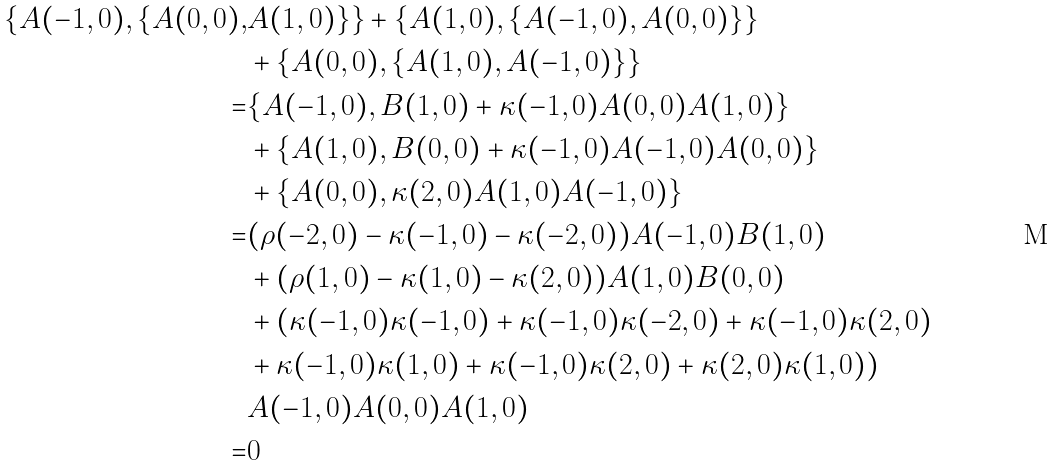<formula> <loc_0><loc_0><loc_500><loc_500>\{ A ( - 1 , 0 ) , \{ A ( 0 , 0 ) , & A ( 1 , 0 ) \} \} + \{ A ( 1 , 0 ) , \{ A ( - 1 , 0 ) , A ( 0 , 0 ) \} \} \\ & + \{ A ( 0 , 0 ) , \{ A ( 1 , 0 ) , A ( - 1 , 0 ) \} \} \\ = & \{ A ( - 1 , 0 ) , B ( 1 , 0 ) + \kappa ( - 1 , 0 ) A ( 0 , 0 ) A ( 1 , 0 ) \} \\ & + \{ A ( 1 , 0 ) , B ( 0 , 0 ) + \kappa ( - 1 , 0 ) A ( - 1 , 0 ) A ( 0 , 0 ) \} \\ & + \{ A ( 0 , 0 ) , \kappa ( 2 , 0 ) A ( 1 , 0 ) A ( - 1 , 0 ) \} \\ = & ( \rho ( - 2 , 0 ) - \kappa ( - 1 , 0 ) - \kappa ( - 2 , 0 ) ) A ( - 1 , 0 ) B ( 1 , 0 ) \\ & + ( \rho ( 1 , 0 ) - \kappa ( 1 , 0 ) - \kappa ( 2 , 0 ) ) A ( 1 , 0 ) B ( 0 , 0 ) \\ & + ( \kappa ( - 1 , 0 ) \kappa ( - 1 , 0 ) + \kappa ( - 1 , 0 ) \kappa ( - 2 , 0 ) + \kappa ( - 1 , 0 ) \kappa ( 2 , 0 ) \\ & + \kappa ( - 1 , 0 ) \kappa ( 1 , 0 ) + \kappa ( - 1 , 0 ) \kappa ( 2 , 0 ) + \kappa ( 2 , 0 ) \kappa ( 1 , 0 ) ) \\ & A ( - 1 , 0 ) A ( 0 , 0 ) A ( 1 , 0 ) \\ = & 0 \\</formula> 